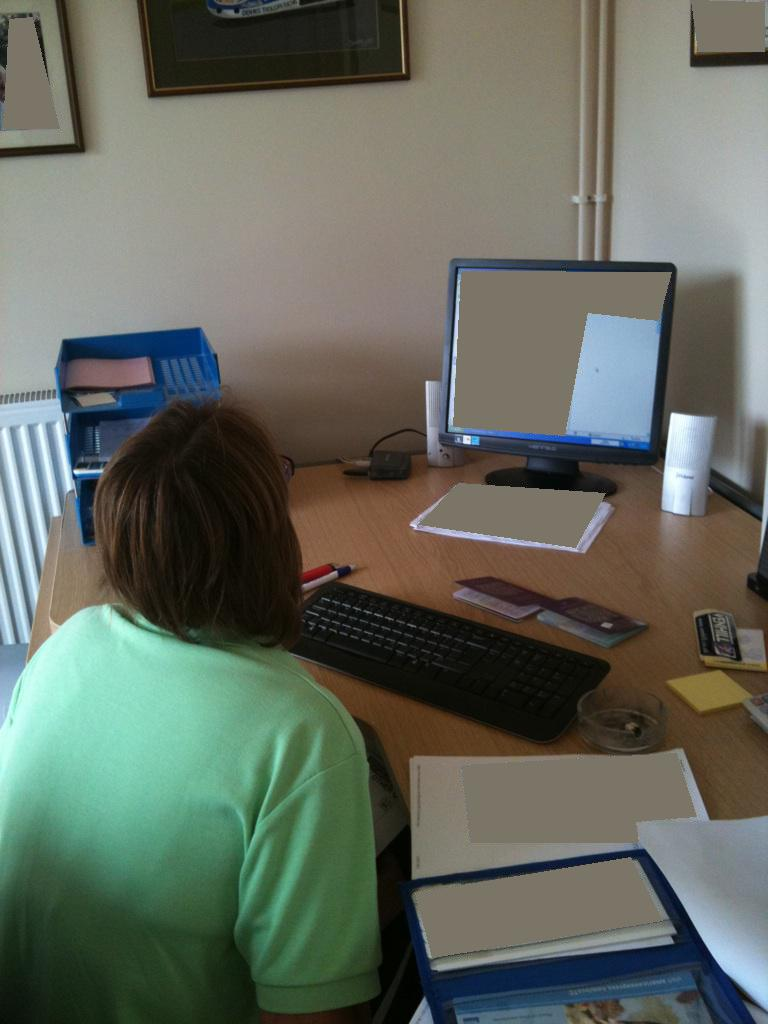What items can you identify on the desk that suggest the nature of the person's work? On the desk, there are multiple documents, possibly related to administrative or clerical tasks, a calendar perhaps used for scheduling, and a notepad for taking notes, which support the notion of an office or administrative environment. 